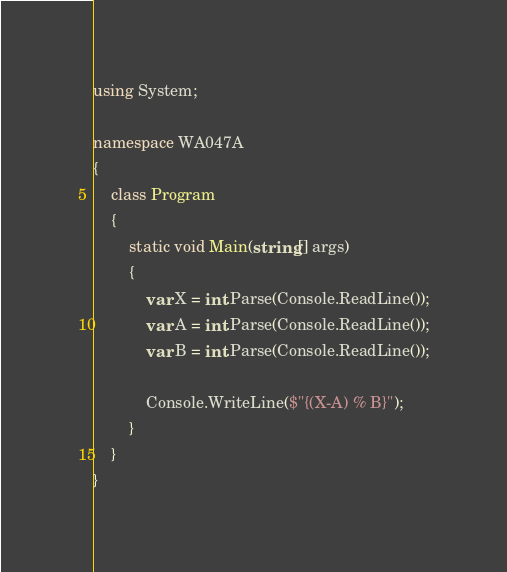<code> <loc_0><loc_0><loc_500><loc_500><_C#_>using System;

namespace WA047A
{
    class Program
    {
        static void Main(string[] args)
        {
            var X = int.Parse(Console.ReadLine());
            var A = int.Parse(Console.ReadLine());
            var B = int.Parse(Console.ReadLine());

            Console.WriteLine($"{(X-A) % B}");
        }
    }
}
</code> 